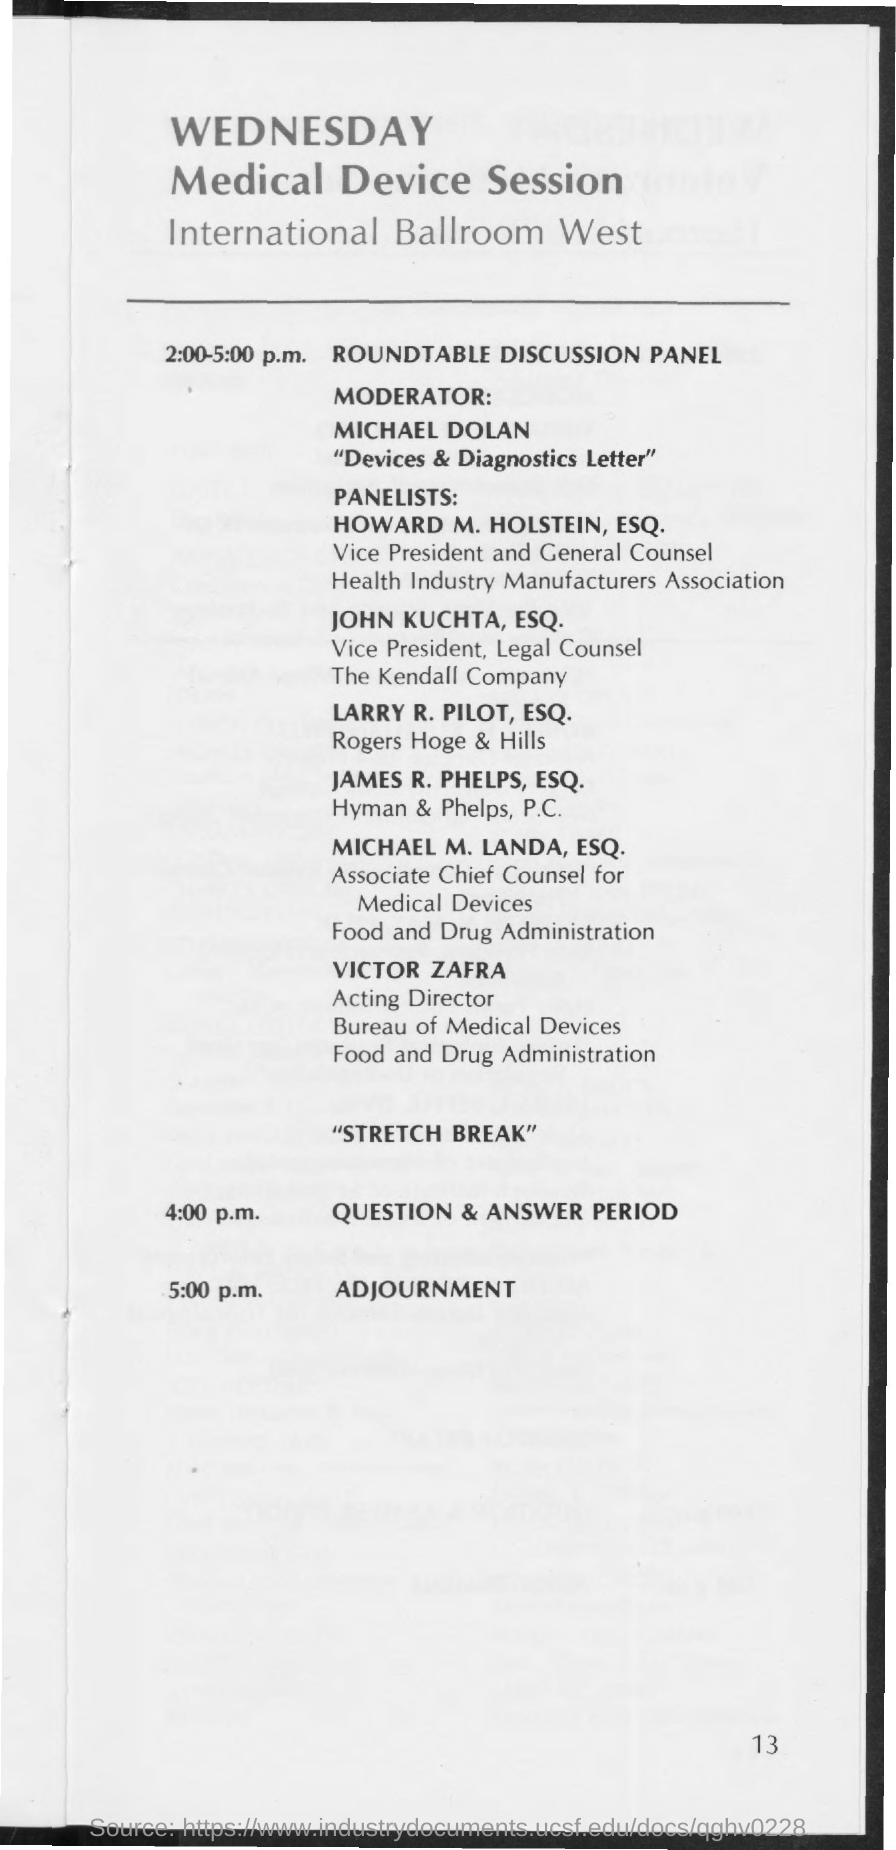Identify some key points in this picture. The roundtable discussion panel will take place from 2:00 p.m. to 5:00 p.m. The adjournment is scheduled for 5:00 p.m... The question and answer period is scheduled for 4:00 PM. The moderator for the roundtable discussion panel is Michael Dolan. 